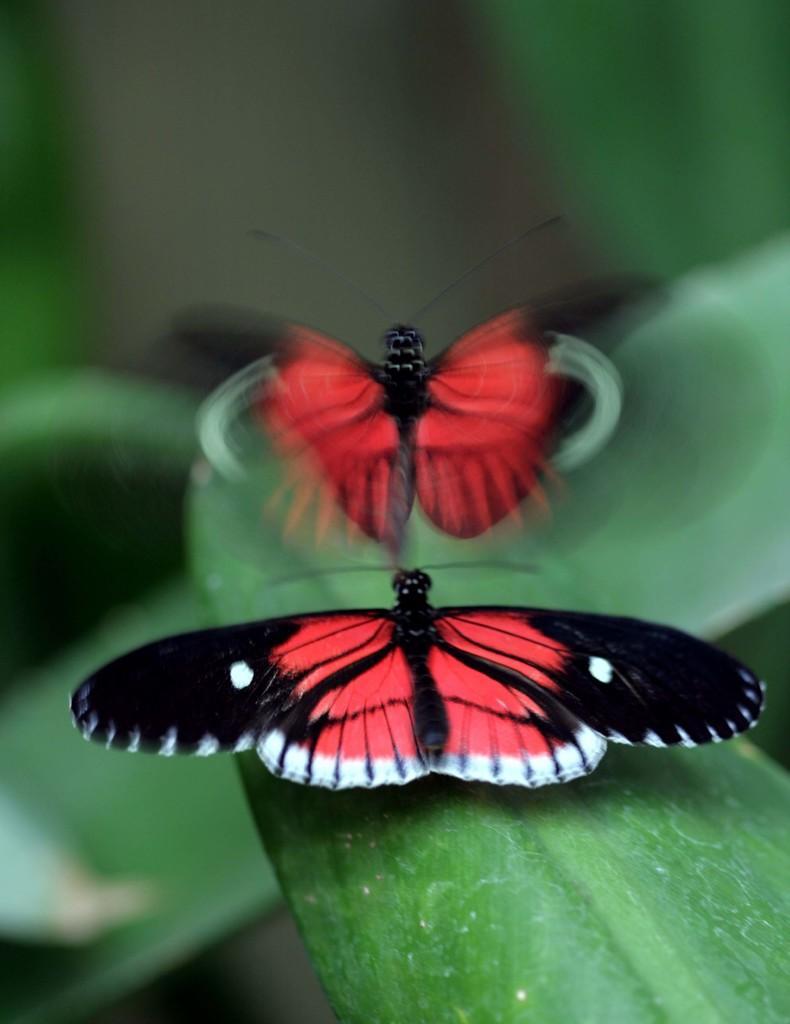Could you give a brief overview of what you see in this image? In this image I can see two butterflies in black and red colors. One is on the leaf and another one is flying. The background is blurred. 